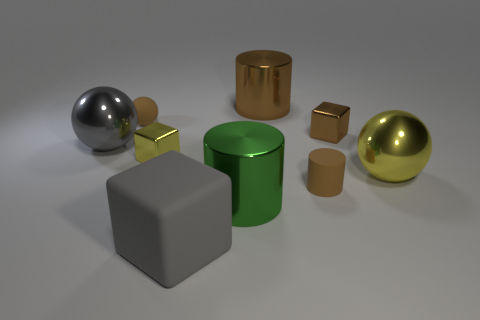What number of large cyan balls are the same material as the big gray block?
Provide a succinct answer. 0. What number of things are metal things to the right of the big block or large gray metal spheres?
Your answer should be compact. 5. What is the size of the brown shiny cylinder?
Keep it short and to the point. Large. The ball to the right of the brown thing that is on the left side of the big green cylinder is made of what material?
Your answer should be compact. Metal. Does the gray object in front of the green object have the same size as the big brown cylinder?
Give a very brief answer. Yes. Are there any large metal balls that have the same color as the big rubber object?
Provide a short and direct response. Yes. How many objects are small matte things that are in front of the tiny ball or metallic cylinders behind the small brown metallic block?
Keep it short and to the point. 2. Is the matte block the same color as the small rubber cylinder?
Provide a succinct answer. No. There is a sphere that is the same color as the large cube; what is its material?
Keep it short and to the point. Metal. Is the number of yellow cubes that are in front of the large green metallic object less than the number of tiny brown metal blocks that are behind the small brown shiny cube?
Make the answer very short. No. 